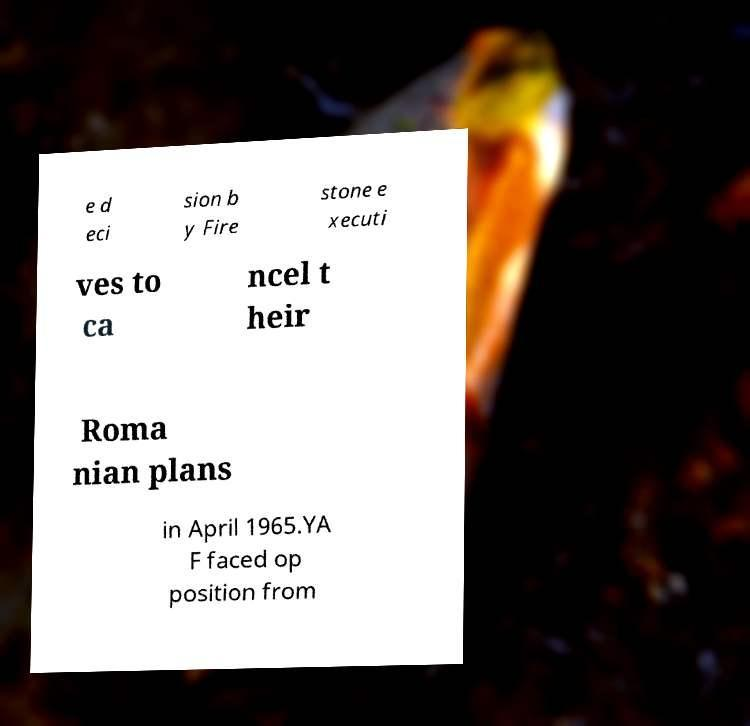Can you read and provide the text displayed in the image?This photo seems to have some interesting text. Can you extract and type it out for me? e d eci sion b y Fire stone e xecuti ves to ca ncel t heir Roma nian plans in April 1965.YA F faced op position from 